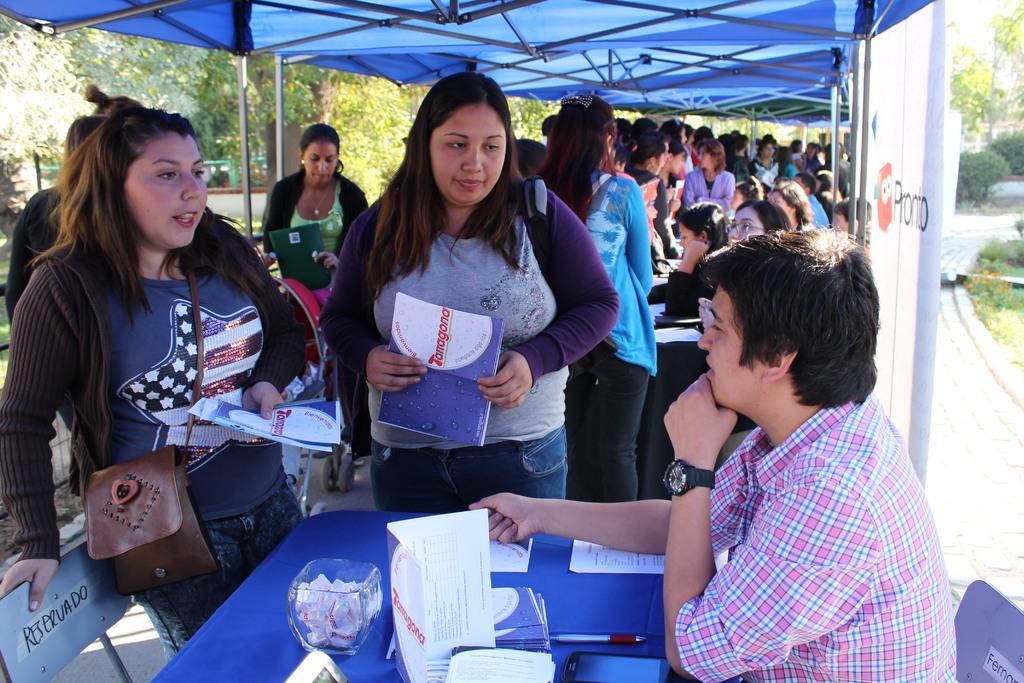In one or two sentences, can you explain what this image depicts? Here in this picture on the right side we can see number of people sitting on chairs with tables in front of them, having papers, pens and bowls present on it over there and in front of them we can see number of people standing with hand bags with them, holding books in their hands present over there and we can see a tent above them present over there and we can see plants and trees present all over there. 